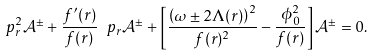Convert formula to latex. <formula><loc_0><loc_0><loc_500><loc_500>\ p _ { r } ^ { 2 } \mathcal { A } ^ { \pm } + \frac { f ^ { \prime } ( r ) } { f ( r ) } \ p _ { r } \mathcal { A } ^ { \pm } + \left [ \frac { \left ( \omega \pm 2 \Lambda ( r ) \right ) ^ { 2 } } { f ( r ) ^ { 2 } } - \frac { \phi _ { 0 } ^ { 2 } } { f ( r ) } \right ] \mathcal { A } ^ { \pm } = 0 .</formula> 